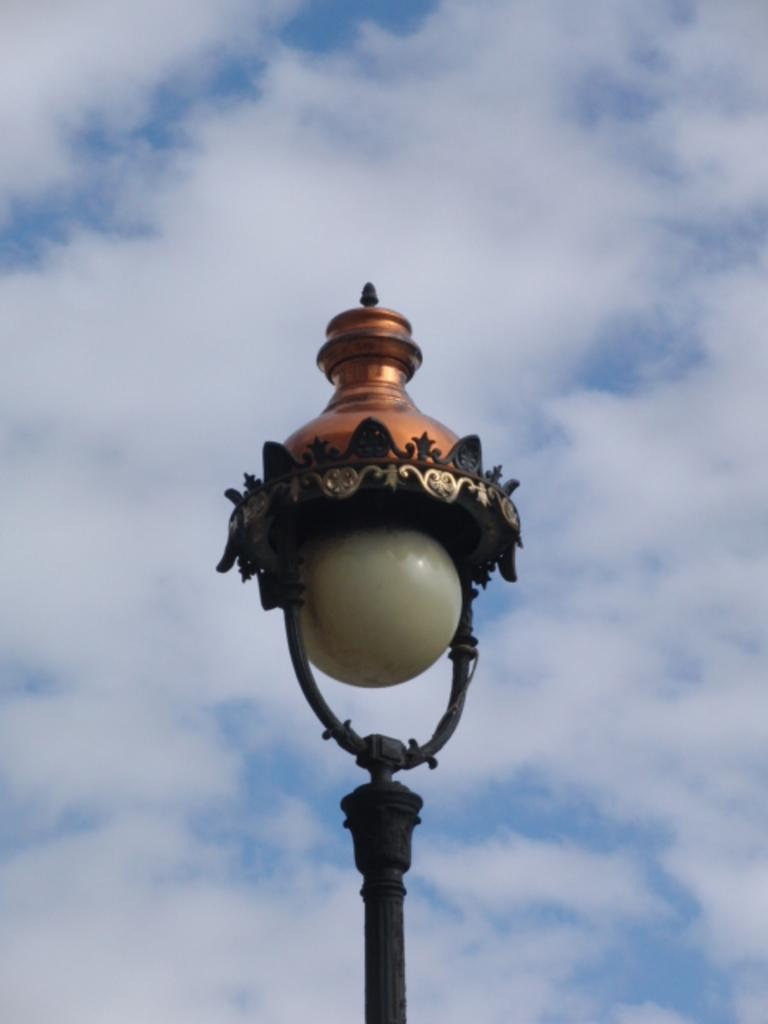What is attached to the pole in the image? There is a lamp attached to the pole in the image. What can be seen behind the lamp? The sky is visible behind the lamp. What is the condition of the sky in the image? The sky is clear in the image. What type of canvas is being painted by the uncle in the image? There is no canvas or uncle present in the image; it only features a pole with a lamp and the clear sky. 